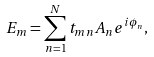Convert formula to latex. <formula><loc_0><loc_0><loc_500><loc_500>E _ { m } = \sum ^ { N } _ { n = 1 } t _ { m n } A _ { n } e ^ { i \phi _ { n } } ,</formula> 